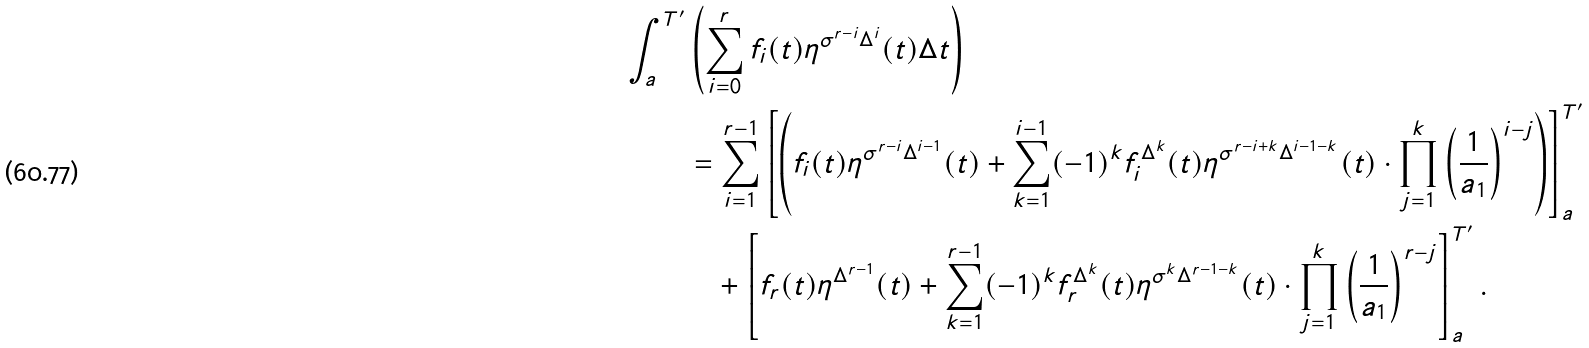Convert formula to latex. <formula><loc_0><loc_0><loc_500><loc_500>\int _ { a } ^ { T ^ { \prime } } & \left ( \sum _ { i = 0 } ^ { r } f _ { i } ( t ) \eta ^ { \sigma ^ { r - i } \Delta ^ { i } } ( t ) \Delta t \right ) \\ & = \sum _ { i = 1 } ^ { r - 1 } \left [ \left ( f _ { i } ( t ) \eta ^ { \sigma ^ { r - i } \Delta ^ { i - 1 } } ( t ) + \sum _ { k = 1 } ^ { i - 1 } ( - 1 ) ^ { k } f _ { i } ^ { \Delta ^ { k } } ( t ) \eta ^ { \sigma ^ { r - i + k } \Delta ^ { i - 1 - k } } ( t ) \cdot \prod _ { j = 1 } ^ { k } \left ( \frac { 1 } { a _ { 1 } } \right ) ^ { i - j } \right ) \right ] _ { a } ^ { T ^ { \prime } } \\ & \quad + \left [ f _ { r } ( t ) \eta ^ { \Delta ^ { r - 1 } } ( t ) + \sum _ { k = 1 } ^ { r - 1 } ( - 1 ) ^ { k } f _ { r } ^ { \Delta ^ { k } } ( t ) \eta ^ { \sigma ^ { k } \Delta ^ { r - 1 - k } } ( t ) \cdot \prod _ { j = 1 } ^ { k } \left ( \frac { 1 } { a _ { 1 } } \right ) ^ { r - j } \right ] _ { a } ^ { T ^ { \prime } } .</formula> 